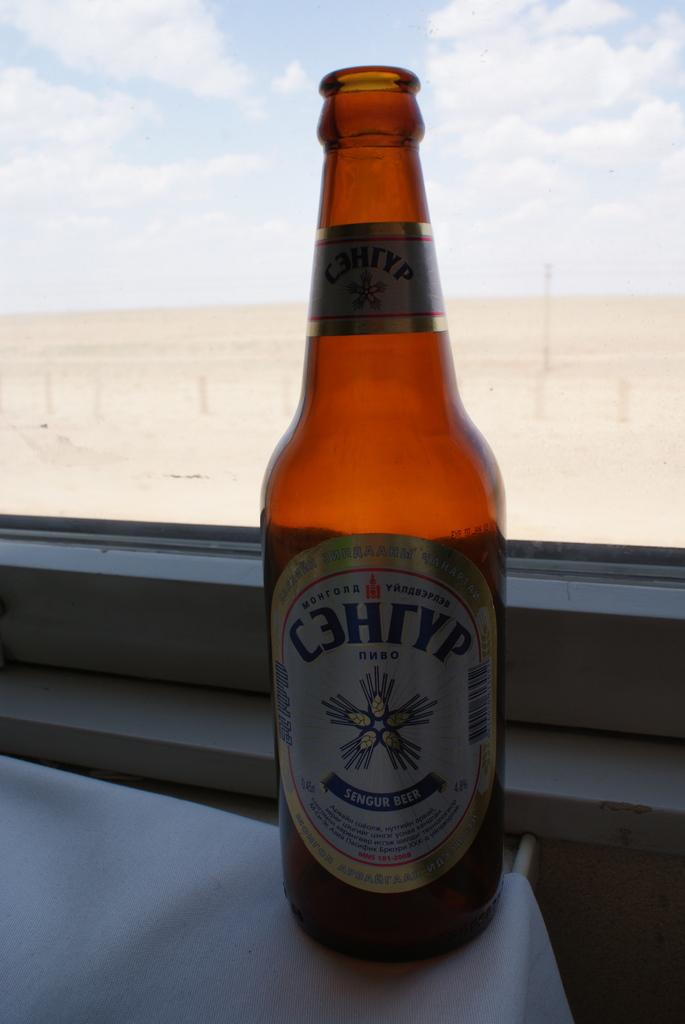<image>
Provide a brief description of the given image. An empty bottle of sengur beer sitting on a windowsill 